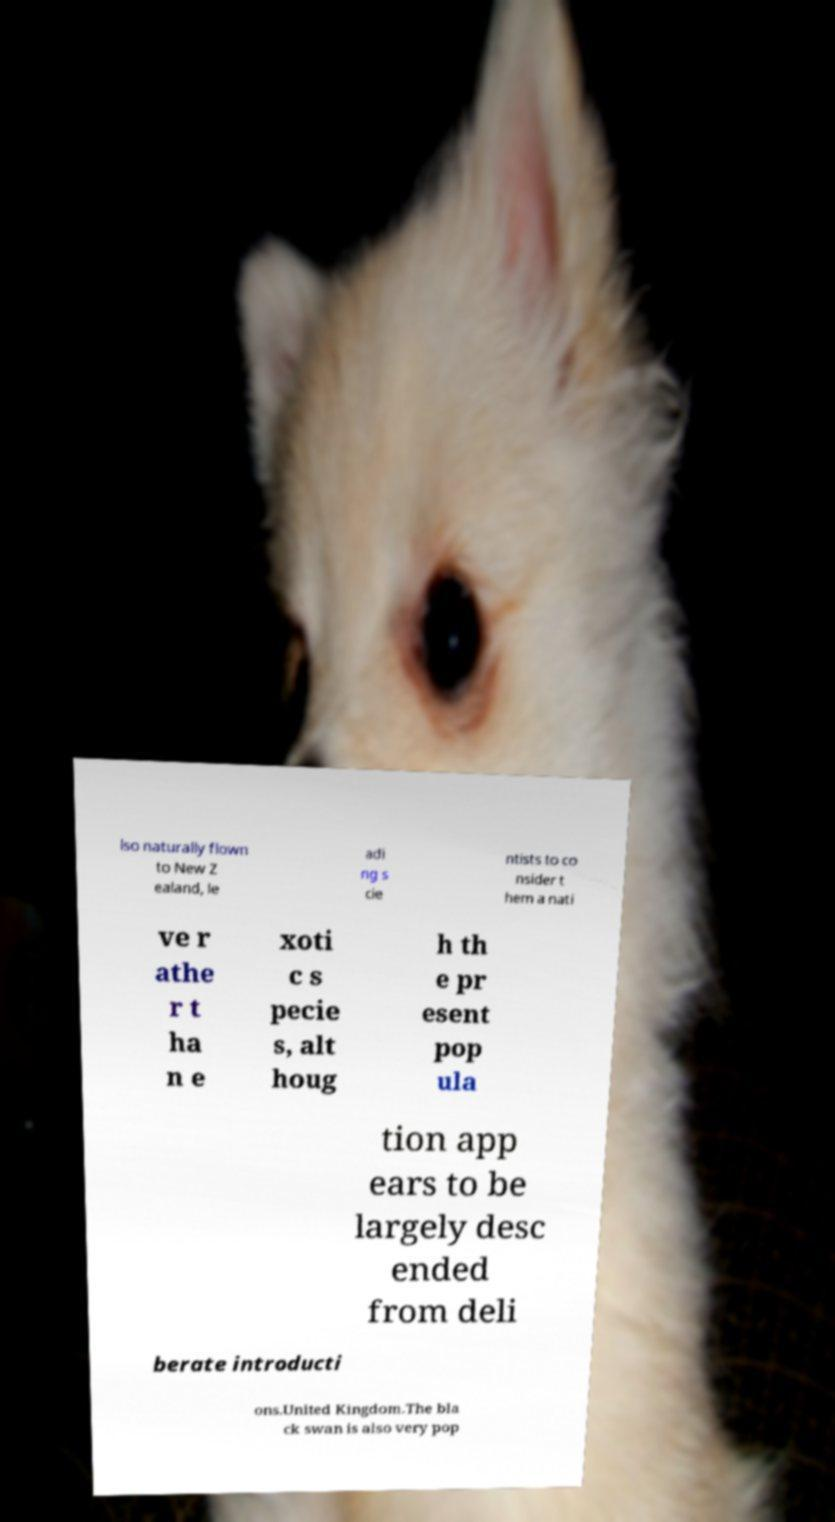Can you read and provide the text displayed in the image?This photo seems to have some interesting text. Can you extract and type it out for me? lso naturally flown to New Z ealand, le adi ng s cie ntists to co nsider t hem a nati ve r athe r t ha n e xoti c s pecie s, alt houg h th e pr esent pop ula tion app ears to be largely desc ended from deli berate introducti ons.United Kingdom.The bla ck swan is also very pop 